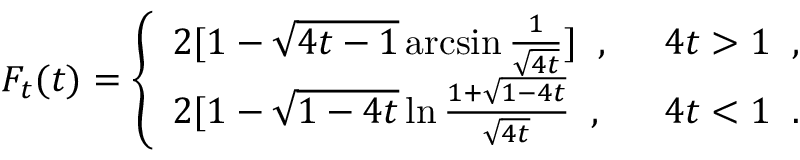<formula> <loc_0><loc_0><loc_500><loc_500>F _ { t } ( t ) = \left \{ \begin{array} { l l } { { 2 [ 1 - \sqrt { 4 t - 1 } \arcsin \frac { 1 } { \sqrt { 4 t } } ] \, , } } & { \, 4 t > 1 \, , } \\ { { 2 [ 1 - \sqrt { 1 - 4 t } \ln \frac { 1 + \sqrt { 1 - 4 t } } { \sqrt { 4 t } } \, , } } & { \, 4 t < 1 \, . } \end{array}</formula> 